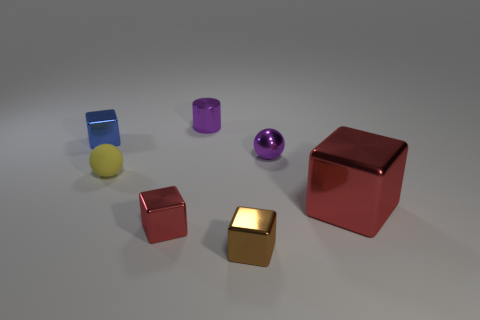There is another red thing that is the same shape as the big red metal object; what is its size?
Make the answer very short. Small. There is a red object that is the same size as the brown shiny block; what is it made of?
Make the answer very short. Metal. What is the material of the other purple object that is the same shape as the rubber object?
Ensure brevity in your answer.  Metal. How many other things are there of the same size as the yellow ball?
Your answer should be very brief. 5. What number of metallic things are the same color as the shiny ball?
Your response must be concise. 1. There is a big object; what shape is it?
Provide a short and direct response. Cube. What color is the small thing that is both behind the tiny rubber ball and to the right of the purple shiny cylinder?
Your answer should be very brief. Purple. What is the material of the tiny purple cylinder?
Ensure brevity in your answer.  Metal. What is the shape of the red thing that is in front of the big cube?
Make the answer very short. Cube. There is a cylinder that is the same size as the brown object; what is its color?
Provide a short and direct response. Purple. 